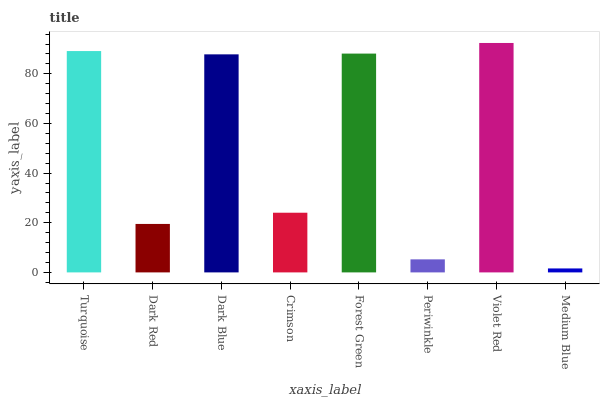Is Dark Red the minimum?
Answer yes or no. No. Is Dark Red the maximum?
Answer yes or no. No. Is Turquoise greater than Dark Red?
Answer yes or no. Yes. Is Dark Red less than Turquoise?
Answer yes or no. Yes. Is Dark Red greater than Turquoise?
Answer yes or no. No. Is Turquoise less than Dark Red?
Answer yes or no. No. Is Dark Blue the high median?
Answer yes or no. Yes. Is Crimson the low median?
Answer yes or no. Yes. Is Periwinkle the high median?
Answer yes or no. No. Is Medium Blue the low median?
Answer yes or no. No. 